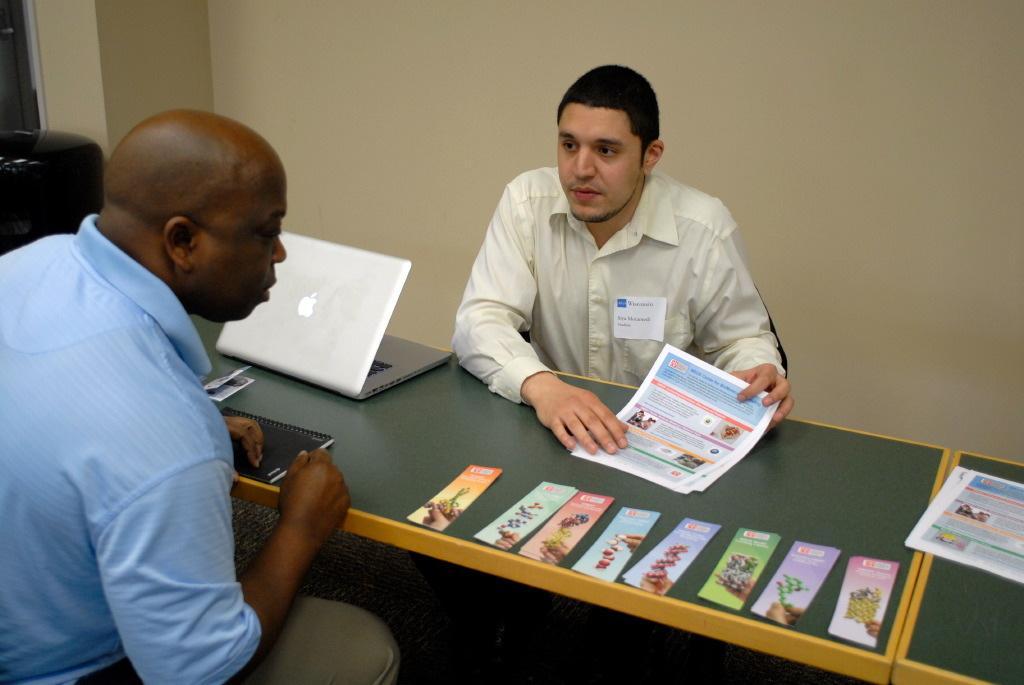Can you describe this image briefly? In this image there are two people sitting, there are objects on the table, there are laptop on the table, there is a table truncated towards the right of the image, there is an object truncated towards the left of the image, there is a wall behind the person. 